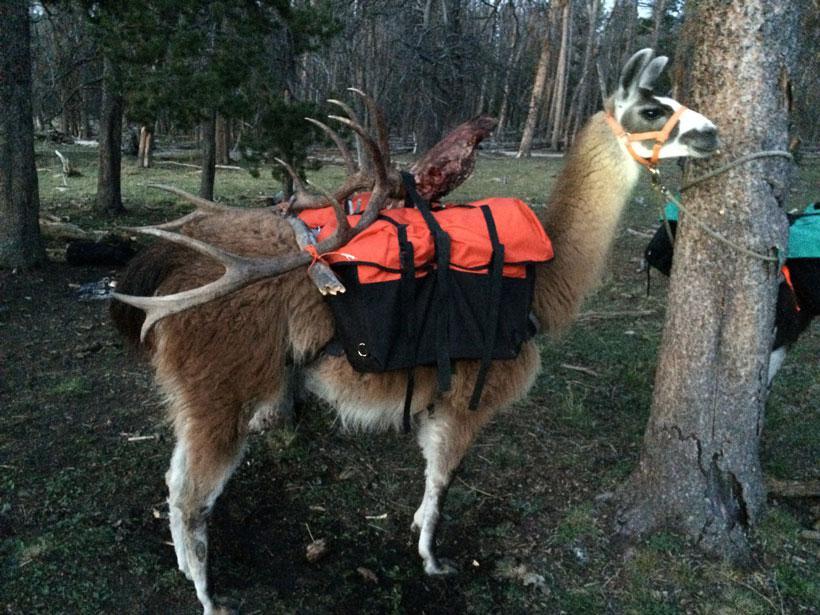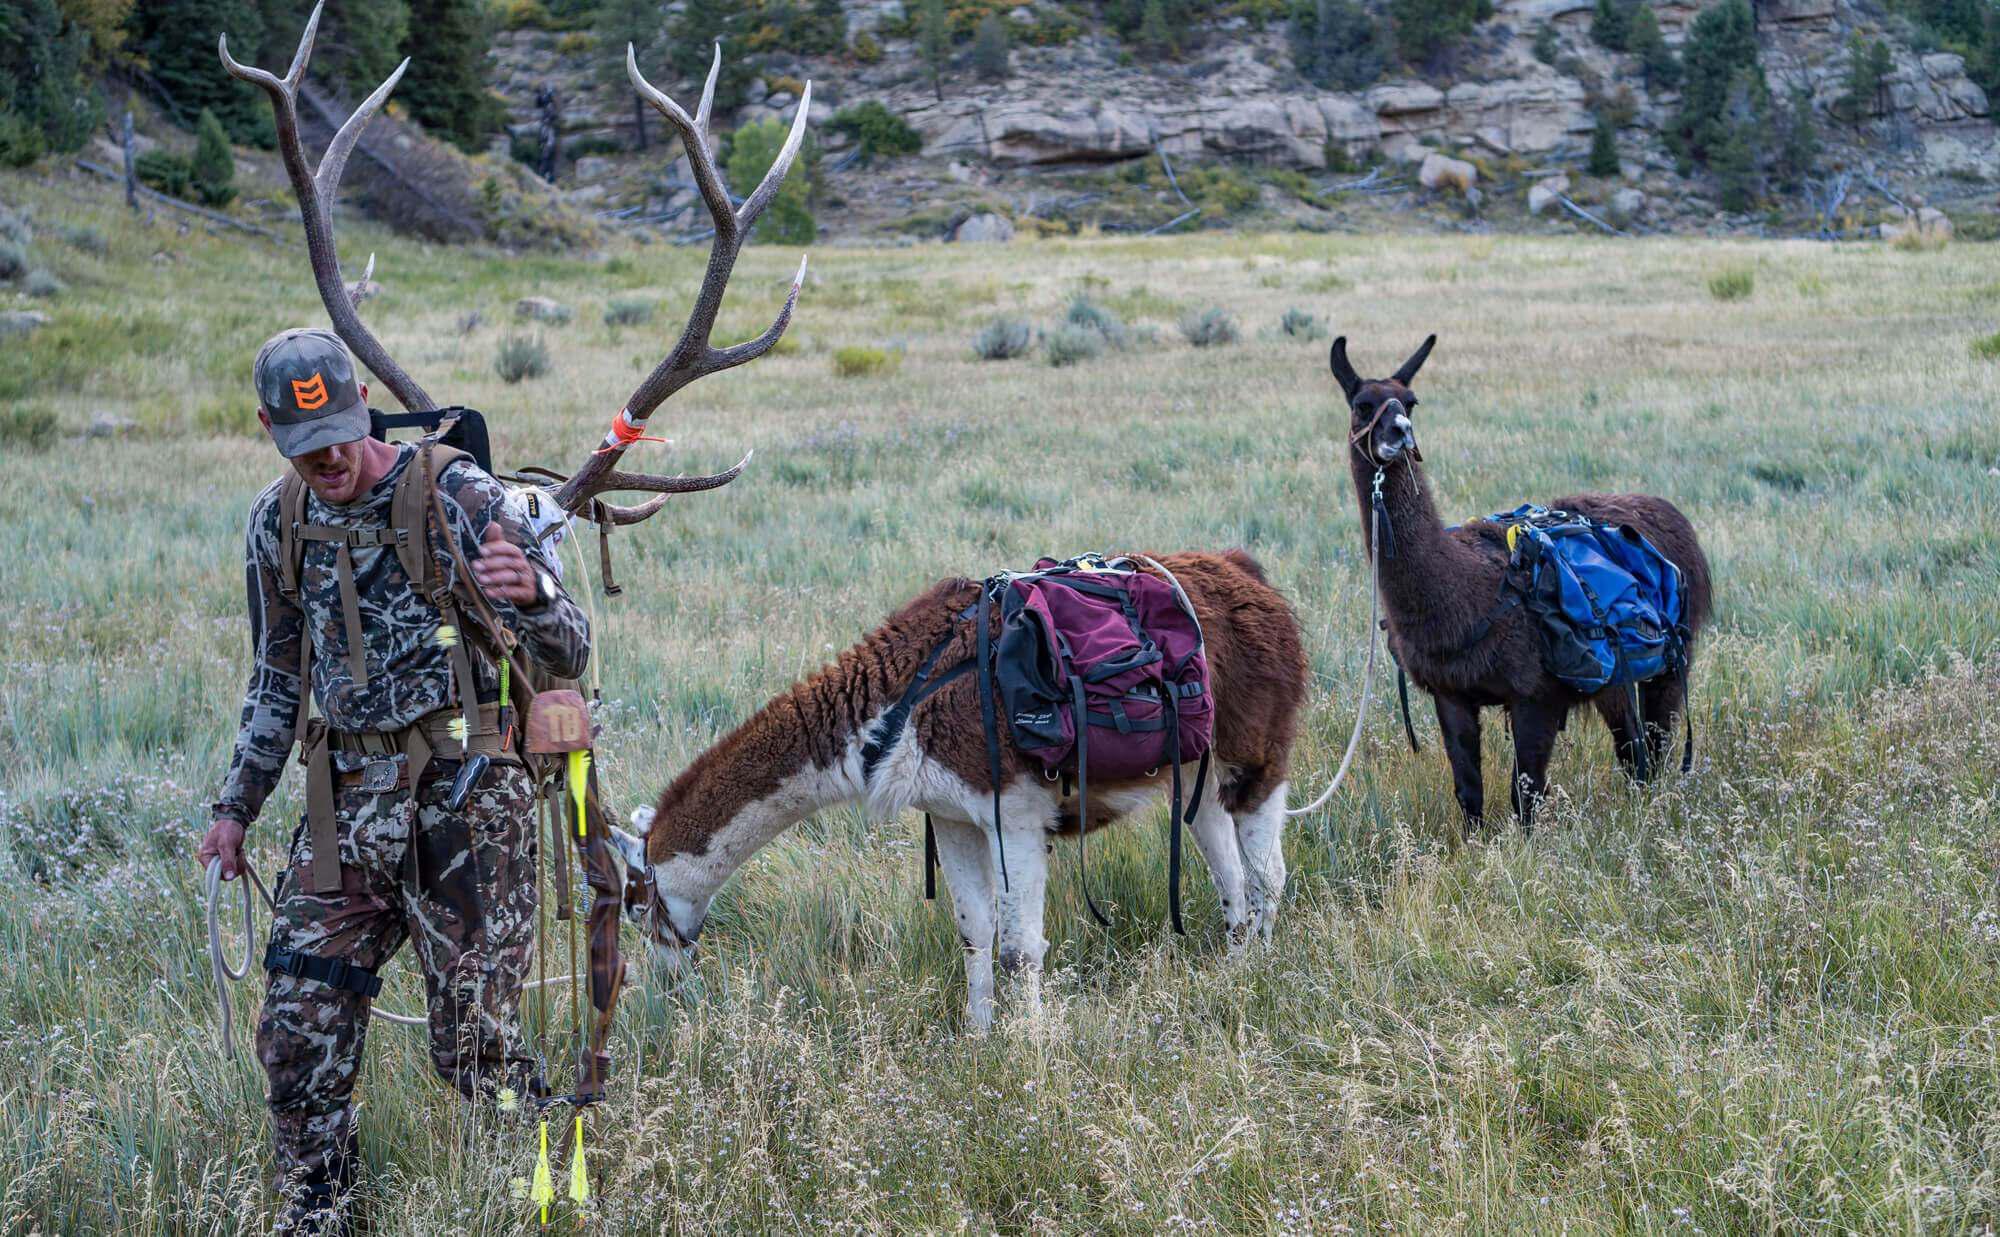The first image is the image on the left, the second image is the image on the right. Given the left and right images, does the statement "There are two alpaca in one image and multiple alpacas in the other image." hold true? Answer yes or no. No. The first image is the image on the left, the second image is the image on the right. Evaluate the accuracy of this statement regarding the images: "One man in camo with a bow is leading no more than two packed llamas leftward in one image.". Is it true? Answer yes or no. Yes. 